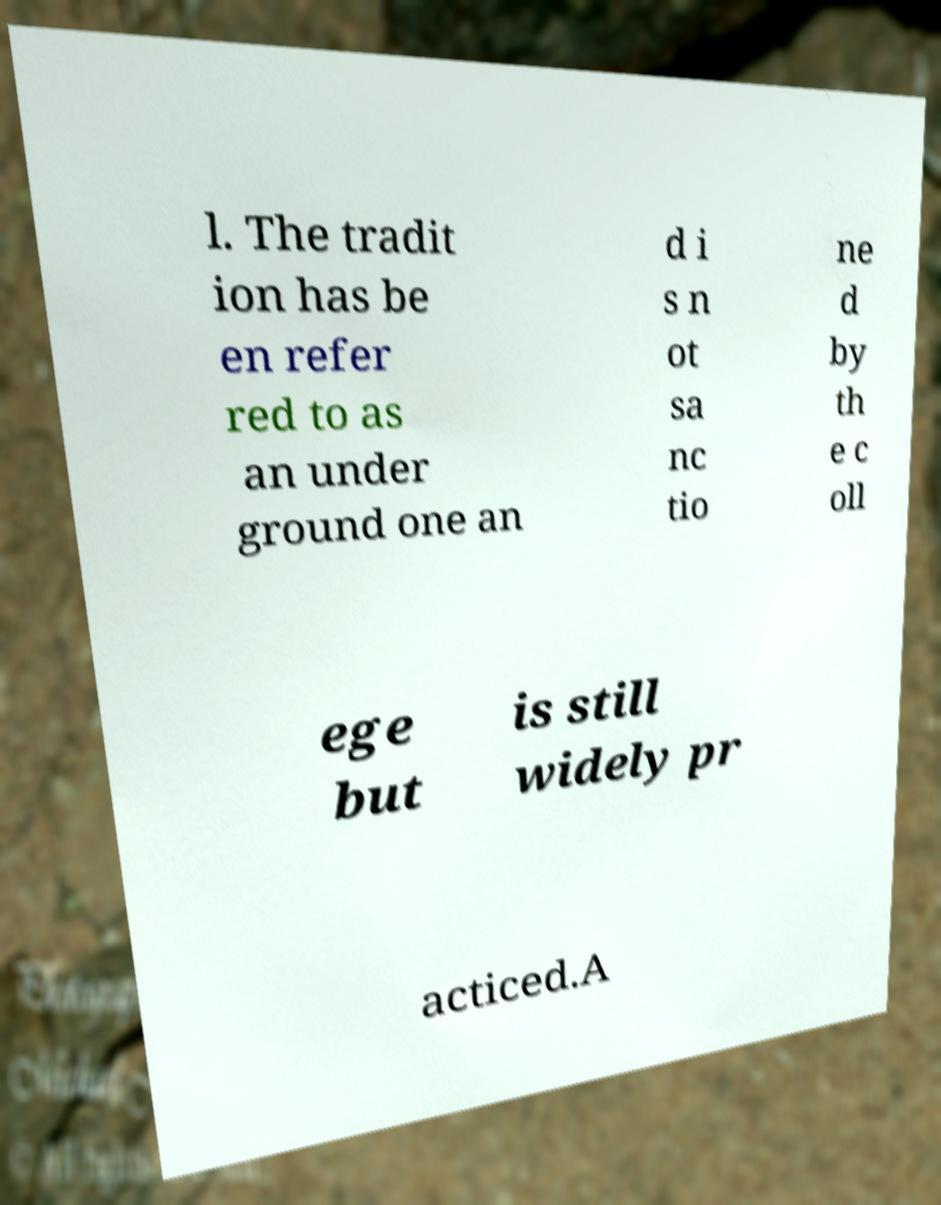Could you extract and type out the text from this image? l. The tradit ion has be en refer red to as an under ground one an d i s n ot sa nc tio ne d by th e c oll ege but is still widely pr acticed.A 